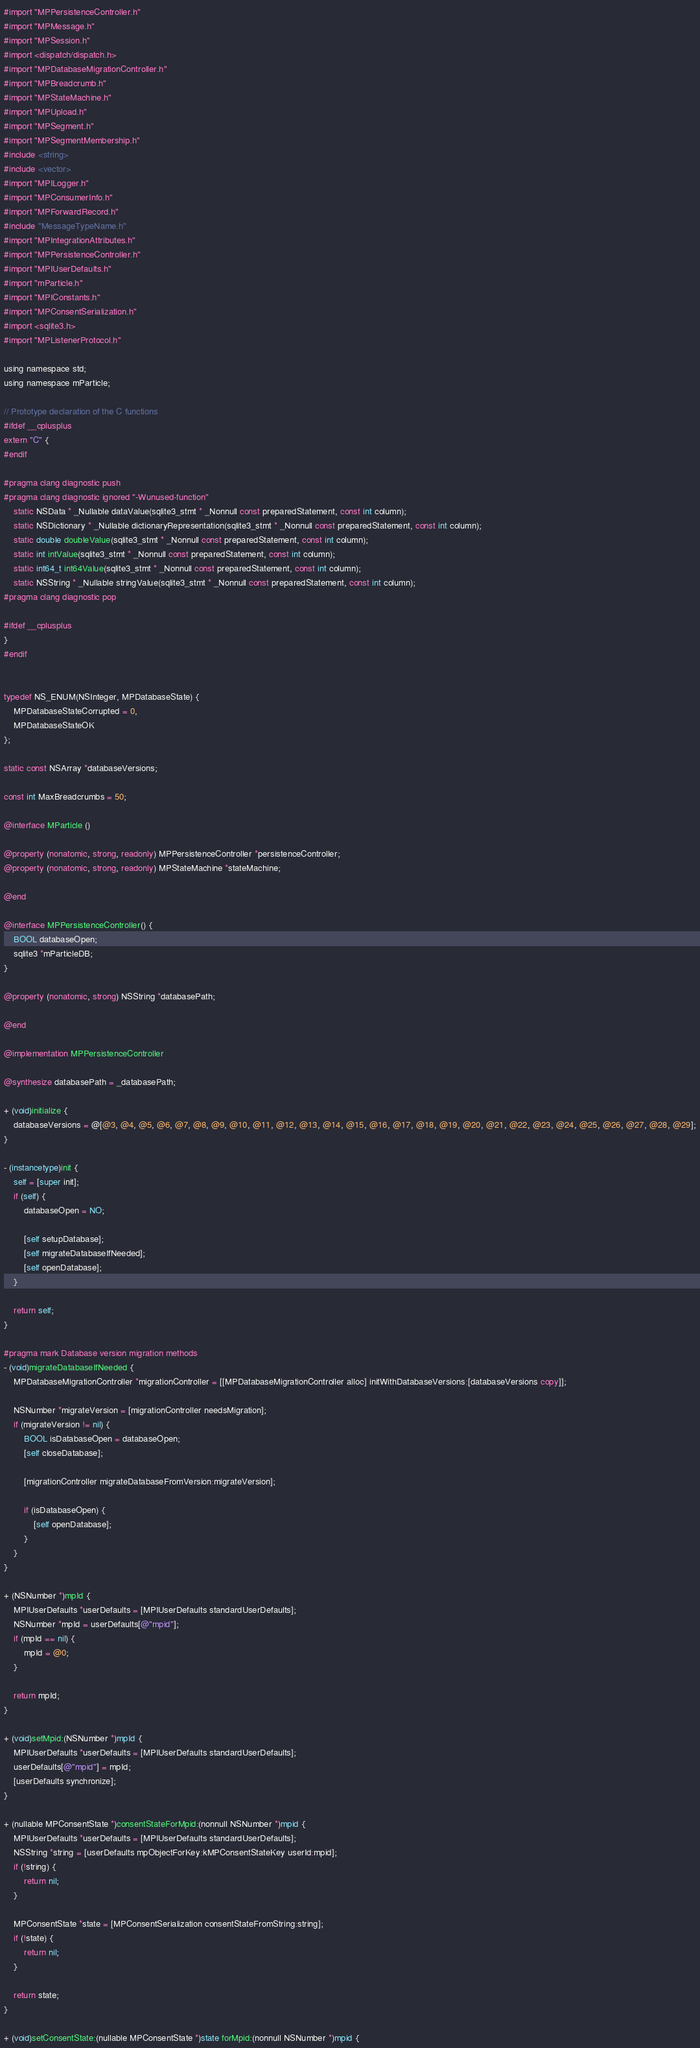<code> <loc_0><loc_0><loc_500><loc_500><_ObjectiveC_>#import "MPPersistenceController.h"
#import "MPMessage.h"
#import "MPSession.h"
#import <dispatch/dispatch.h>
#import "MPDatabaseMigrationController.h"
#import "MPBreadcrumb.h"
#import "MPStateMachine.h"
#import "MPUpload.h"
#import "MPSegment.h"
#import "MPSegmentMembership.h"
#include <string>
#include <vector>
#import "MPILogger.h"
#import "MPConsumerInfo.h"
#import "MPForwardRecord.h"
#include "MessageTypeName.h"
#import "MPIntegrationAttributes.h"
#import "MPPersistenceController.h"
#import "MPIUserDefaults.h"
#import "mParticle.h"
#import "MPIConstants.h"
#import "MPConsentSerialization.h"
#import <sqlite3.h>
#import "MPListenerProtocol.h"

using namespace std;
using namespace mParticle;

// Prototype declaration of the C functions
#ifdef __cplusplus
extern "C" {
#endif
    
#pragma clang diagnostic push
#pragma clang diagnostic ignored "-Wunused-function"
    static NSData * _Nullable dataValue(sqlite3_stmt * _Nonnull const preparedStatement, const int column);
    static NSDictionary * _Nullable dictionaryRepresentation(sqlite3_stmt * _Nonnull const preparedStatement, const int column);
    static double doubleValue(sqlite3_stmt * _Nonnull const preparedStatement, const int column);
    static int intValue(sqlite3_stmt * _Nonnull const preparedStatement, const int column);
    static int64_t int64Value(sqlite3_stmt * _Nonnull const preparedStatement, const int column);
    static NSString * _Nullable stringValue(sqlite3_stmt * _Nonnull const preparedStatement, const int column);
#pragma clang diagnostic pop
    
#ifdef __cplusplus
}
#endif


typedef NS_ENUM(NSInteger, MPDatabaseState) {
    MPDatabaseStateCorrupted = 0,
    MPDatabaseStateOK
};

static const NSArray *databaseVersions;

const int MaxBreadcrumbs = 50;

@interface MParticle ()

@property (nonatomic, strong, readonly) MPPersistenceController *persistenceController;
@property (nonatomic, strong, readonly) MPStateMachine *stateMachine;

@end

@interface MPPersistenceController() {
    BOOL databaseOpen;
    sqlite3 *mParticleDB;
}

@property (nonatomic, strong) NSString *databasePath;

@end

@implementation MPPersistenceController

@synthesize databasePath = _databasePath;

+ (void)initialize {
    databaseVersions = @[@3, @4, @5, @6, @7, @8, @9, @10, @11, @12, @13, @14, @15, @16, @17, @18, @19, @20, @21, @22, @23, @24, @25, @26, @27, @28, @29];
}

- (instancetype)init {
    self = [super init];
    if (self) {
        databaseOpen = NO;
        
        [self setupDatabase];
        [self migrateDatabaseIfNeeded];
        [self openDatabase];
    }
    
    return self;
}

#pragma mark Database version migration methods
- (void)migrateDatabaseIfNeeded {
    MPDatabaseMigrationController *migrationController = [[MPDatabaseMigrationController alloc] initWithDatabaseVersions:[databaseVersions copy]];
    
    NSNumber *migrateVersion = [migrationController needsMigration];
    if (migrateVersion != nil) {
        BOOL isDatabaseOpen = databaseOpen;
        [self closeDatabase];
        
        [migrationController migrateDatabaseFromVersion:migrateVersion];
        
        if (isDatabaseOpen) {
            [self openDatabase];
        }
    }
}

+ (NSNumber *)mpId {
    MPIUserDefaults *userDefaults = [MPIUserDefaults standardUserDefaults];
    NSNumber *mpId = userDefaults[@"mpid"];
    if (mpId == nil) {
        mpId = @0;
    }
    
    return mpId;
}

+ (void)setMpid:(NSNumber *)mpId {
    MPIUserDefaults *userDefaults = [MPIUserDefaults standardUserDefaults];
    userDefaults[@"mpid"] = mpId;
    [userDefaults synchronize];
}

+ (nullable MPConsentState *)consentStateForMpid:(nonnull NSNumber *)mpid {
    MPIUserDefaults *userDefaults = [MPIUserDefaults standardUserDefaults];
    NSString *string = [userDefaults mpObjectForKey:kMPConsentStateKey userId:mpid];
    if (!string) {
        return nil;
    }
    
    MPConsentState *state = [MPConsentSerialization consentStateFromString:string];
    if (!state) {
        return nil;
    }
    
    return state;
}

+ (void)setConsentState:(nullable MPConsentState *)state forMpid:(nonnull NSNumber *)mpid {</code> 